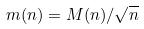Convert formula to latex. <formula><loc_0><loc_0><loc_500><loc_500>m ( n ) = M ( n ) / \sqrt { n }</formula> 